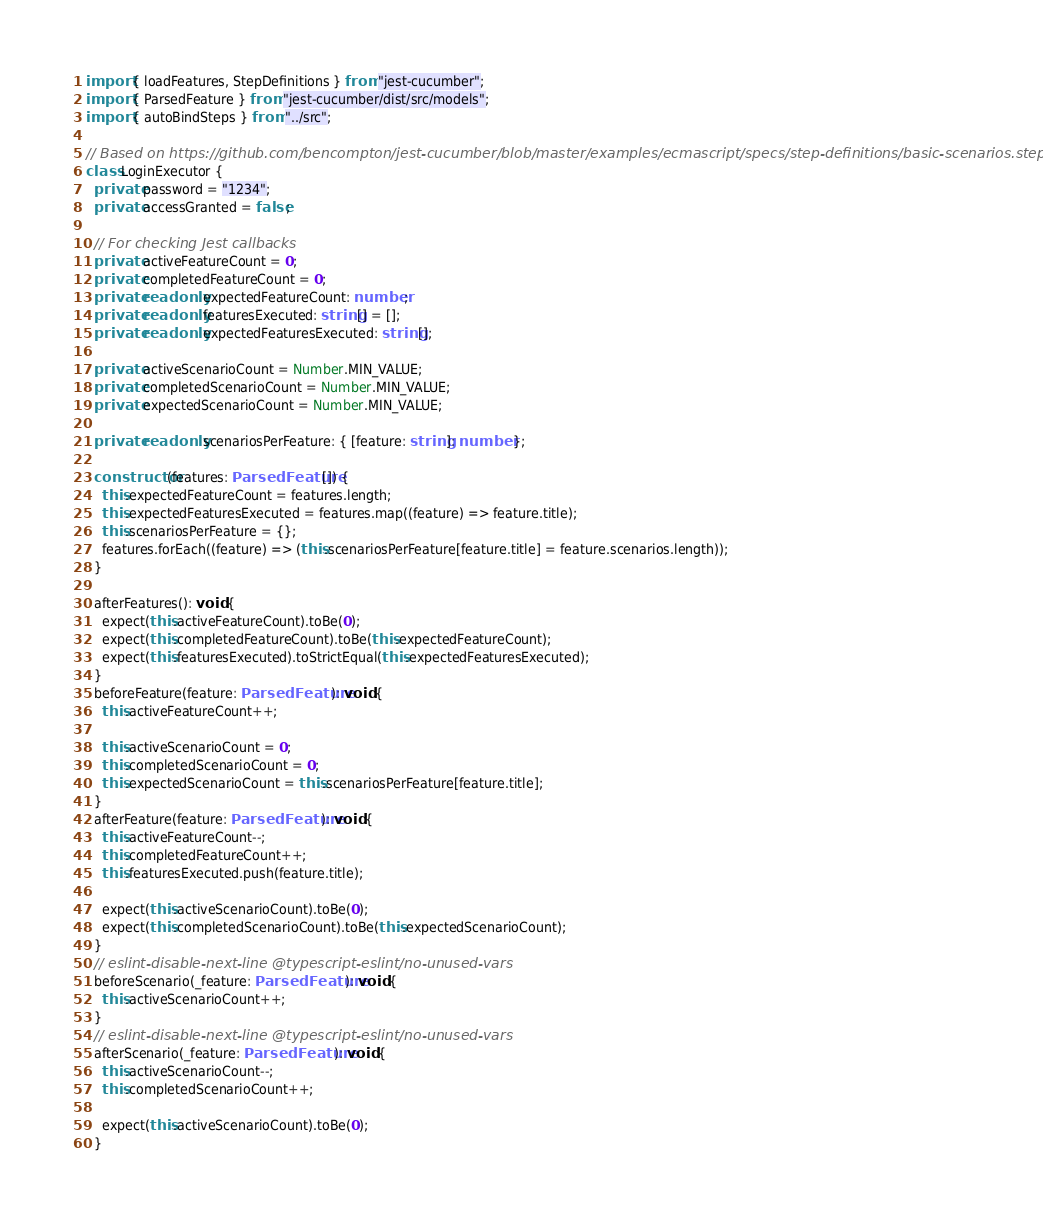Convert code to text. <code><loc_0><loc_0><loc_500><loc_500><_TypeScript_>import { loadFeatures, StepDefinitions } from "jest-cucumber";
import { ParsedFeature } from "jest-cucumber/dist/src/models";
import { autoBindSteps } from "../src";

// Based on https://github.com/bencompton/jest-cucumber/blob/master/examples/ecmascript/specs/step-definitions/basic-scenarios.steps.js
class LoginExecutor {
  private password = "1234";
  private accessGranted = false;

  // For checking Jest callbacks
  private activeFeatureCount = 0;
  private completedFeatureCount = 0;
  private readonly expectedFeatureCount: number;
  private readonly featuresExecuted: string[] = [];
  private readonly expectedFeaturesExecuted: string[];

  private activeScenarioCount = Number.MIN_VALUE;
  private completedScenarioCount = Number.MIN_VALUE;
  private expectedScenarioCount = Number.MIN_VALUE;

  private readonly scenariosPerFeature: { [feature: string]: number };

  constructor(features: ParsedFeature[]) {
    this.expectedFeatureCount = features.length;
    this.expectedFeaturesExecuted = features.map((feature) => feature.title);
    this.scenariosPerFeature = {};
    features.forEach((feature) => (this.scenariosPerFeature[feature.title] = feature.scenarios.length));
  }

  afterFeatures(): void {
    expect(this.activeFeatureCount).toBe(0);
    expect(this.completedFeatureCount).toBe(this.expectedFeatureCount);
    expect(this.featuresExecuted).toStrictEqual(this.expectedFeaturesExecuted);
  }
  beforeFeature(feature: ParsedFeature): void {
    this.activeFeatureCount++;

    this.activeScenarioCount = 0;
    this.completedScenarioCount = 0;
    this.expectedScenarioCount = this.scenariosPerFeature[feature.title];
  }
  afterFeature(feature: ParsedFeature): void {
    this.activeFeatureCount--;
    this.completedFeatureCount++;
    this.featuresExecuted.push(feature.title);

    expect(this.activeScenarioCount).toBe(0);
    expect(this.completedScenarioCount).toBe(this.expectedScenarioCount);
  }
  // eslint-disable-next-line @typescript-eslint/no-unused-vars
  beforeScenario(_feature: ParsedFeature): void {
    this.activeScenarioCount++;
  }
  // eslint-disable-next-line @typescript-eslint/no-unused-vars
  afterScenario(_feature: ParsedFeature): void {
    this.activeScenarioCount--;
    this.completedScenarioCount++;

    expect(this.activeScenarioCount).toBe(0);
  }
</code> 